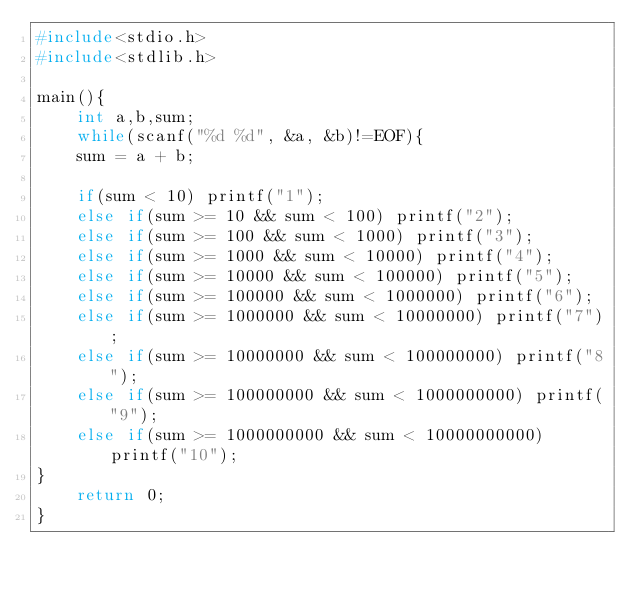Convert code to text. <code><loc_0><loc_0><loc_500><loc_500><_C_>#include<stdio.h>
#include<stdlib.h>

main(){
	int a,b,sum;
	while(scanf("%d %d", &a, &b)!=EOF){
	sum = a + b;
	
	if(sum < 10) printf("1");
	else if(sum >= 10 && sum < 100) printf("2");
	else if(sum >= 100 && sum < 1000) printf("3");
	else if(sum >= 1000 && sum < 10000) printf("4");
	else if(sum >= 10000 && sum < 100000) printf("5");
	else if(sum >= 100000 && sum < 1000000) printf("6");
	else if(sum >= 1000000 && sum < 10000000) printf("7");
	else if(sum >= 10000000 && sum < 100000000) printf("8");
	else if(sum >= 100000000 && sum < 1000000000) printf("9");
	else if(sum >= 1000000000 && sum < 10000000000) printf("10");
}
	return 0;
} 
</code> 